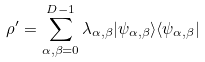Convert formula to latex. <formula><loc_0><loc_0><loc_500><loc_500>\rho ^ { \prime } = \sum _ { \alpha , \beta = 0 } ^ { D - 1 } \lambda _ { \alpha , \beta } | \psi _ { \alpha , \beta } \rangle \langle \psi _ { \alpha , \beta } |</formula> 